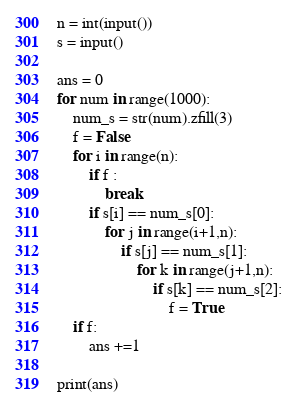Convert code to text. <code><loc_0><loc_0><loc_500><loc_500><_Python_>n = int(input())
s = input()

ans = 0
for num in range(1000):
    num_s = str(num).zfill(3)
    f = False
    for i in range(n):
        if f :
            break
        if s[i] == num_s[0]:
            for j in range(i+1,n):
                if s[j] == num_s[1]:
                    for k in range(j+1,n):
                        if s[k] == num_s[2]:
                            f = True
    if f:
        ans +=1
    
print(ans)
</code> 